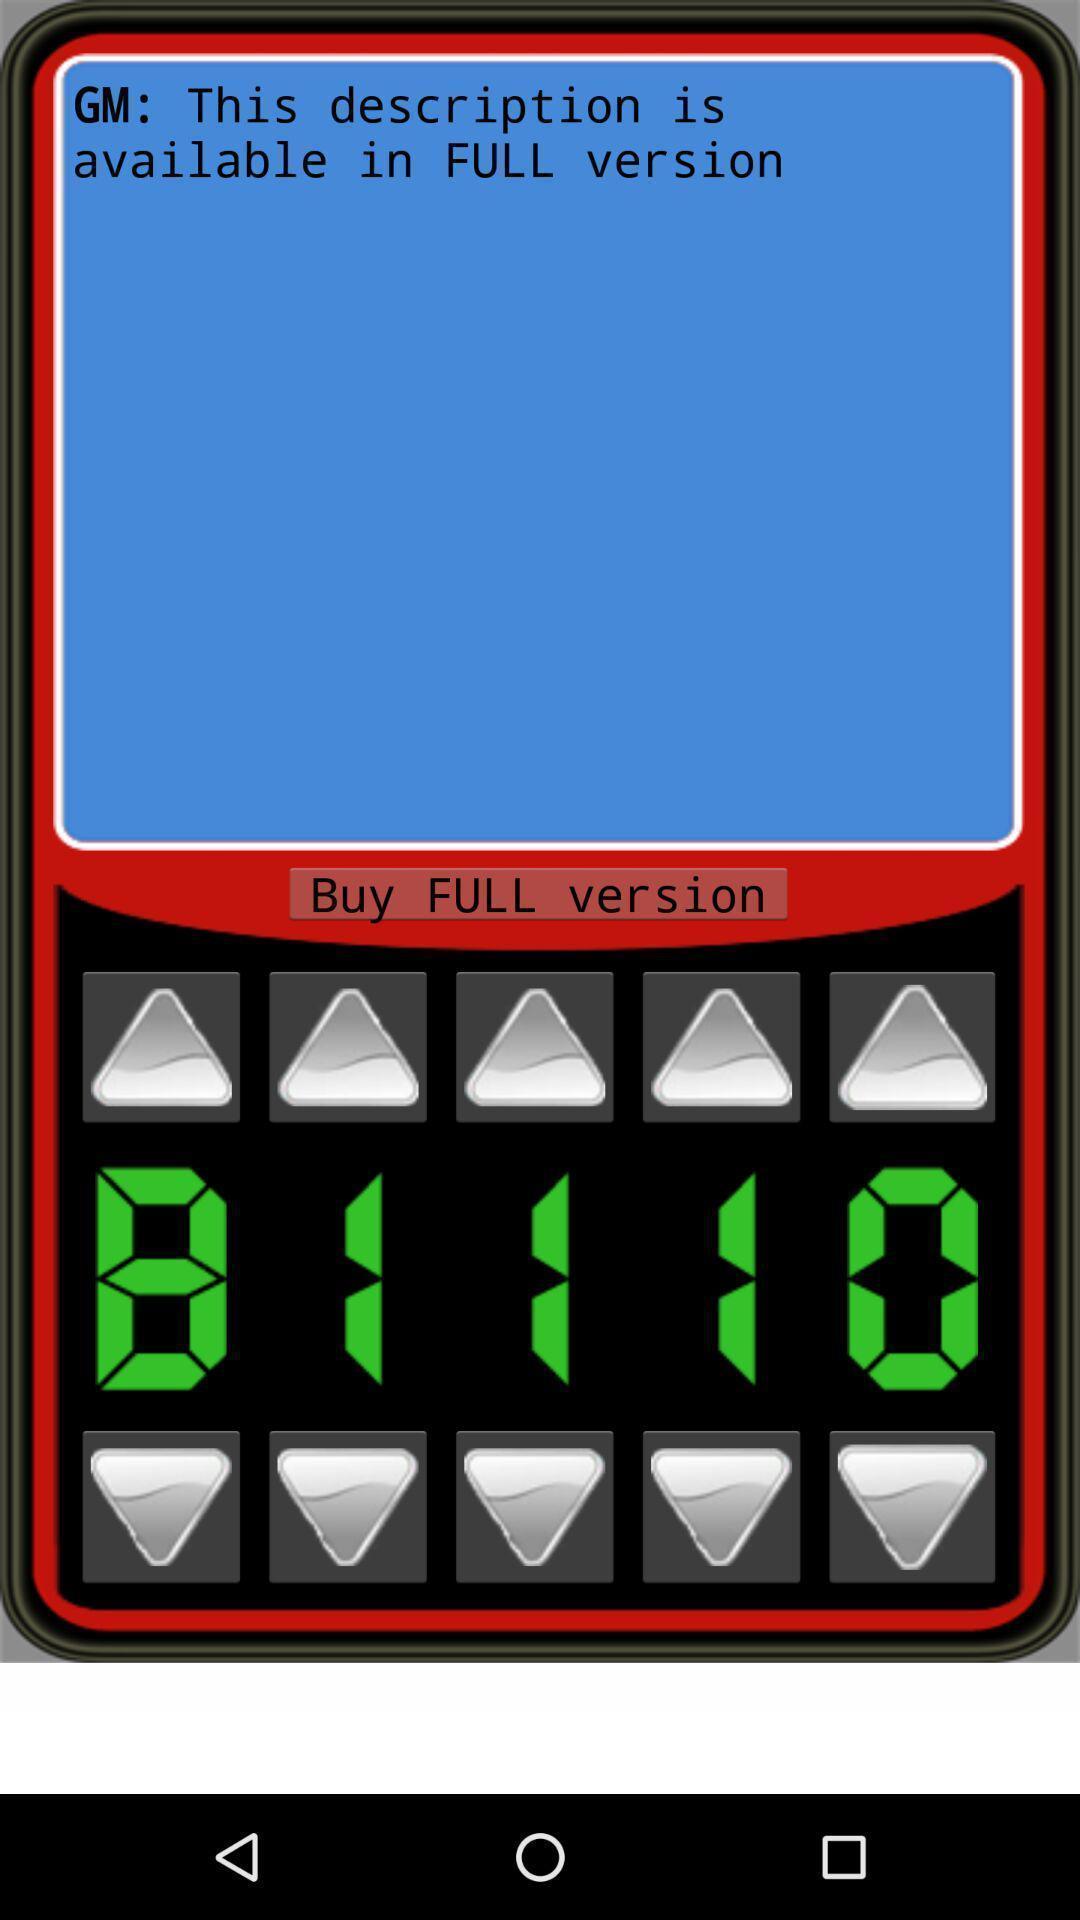Describe the visual elements of this screenshot. Page that displaying an image. 